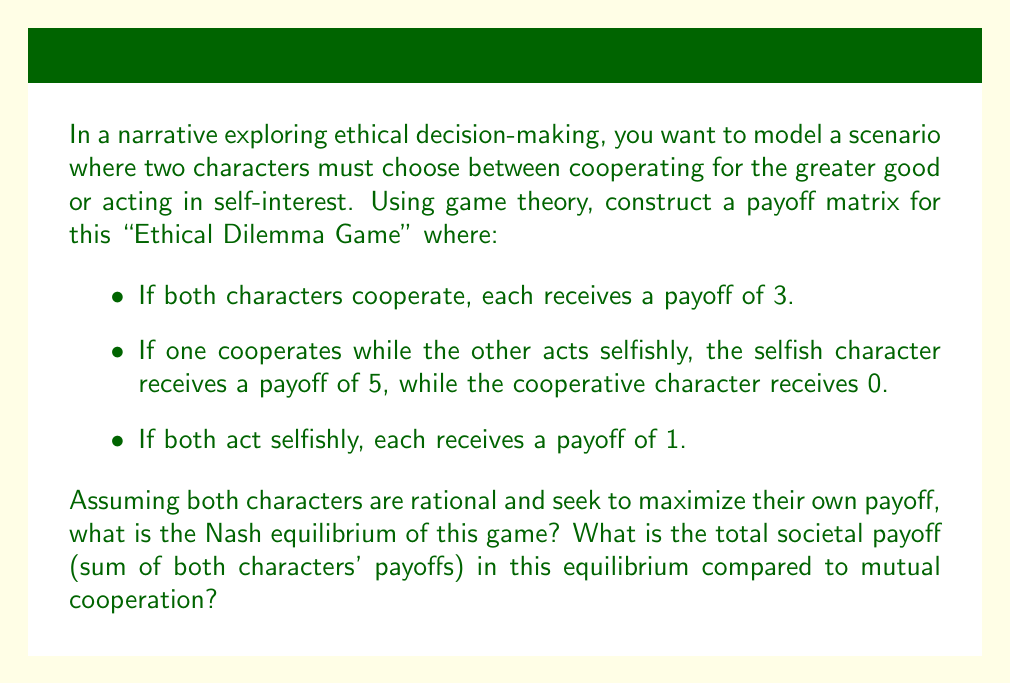Can you answer this question? To solve this problem, we need to follow these steps:

1. Construct the payoff matrix
2. Identify the Nash equilibrium
3. Calculate the total societal payoff for the Nash equilibrium and mutual cooperation

Step 1: Constructing the payoff matrix

Let's denote the two characters as A and B, and their strategies as Cooperate (C) and Selfish (S). The payoff matrix will look like this:

$$
\begin{array}{c|c|c}
A \backslash B & \text{Cooperate} & \text{Selfish} \\
\hline
\text{Cooperate} & (3,3) & (0,5) \\
\hline
\text{Selfish} & (5,0) & (1,1)
\end{array}
$$

Step 2: Identifying the Nash equilibrium

A Nash equilibrium is a set of strategies where no player can unilaterally change their strategy to increase their payoff. To find it, we need to consider each player's best response to the other's strategy:

- If B cooperates, A's best response is to act selfishly (5 > 3)
- If B acts selfishly, A's best response is to act selfishly (1 > 0)
- If A cooperates, B's best response is to act selfishly (5 > 3)
- If A acts selfishly, B's best response is to act selfishly (1 > 0)

We can see that regardless of what the other player does, acting selfishly is always the best response. Therefore, the Nash equilibrium is (Selfish, Selfish), resulting in payoffs of (1,1).

Step 3: Calculating total societal payoff

For the Nash equilibrium (Selfish, Selfish):
Total societal payoff = 1 + 1 = 2

For mutual cooperation (Cooperate, Cooperate):
Total societal payoff = 3 + 3 = 6

The difference in total societal payoff is 6 - 2 = 4.
Answer: The Nash equilibrium of this game is (Selfish, Selfish), resulting in payoffs of (1,1). The total societal payoff in this equilibrium is 2, which is 4 less than the total societal payoff of 6 that would result from mutual cooperation. 